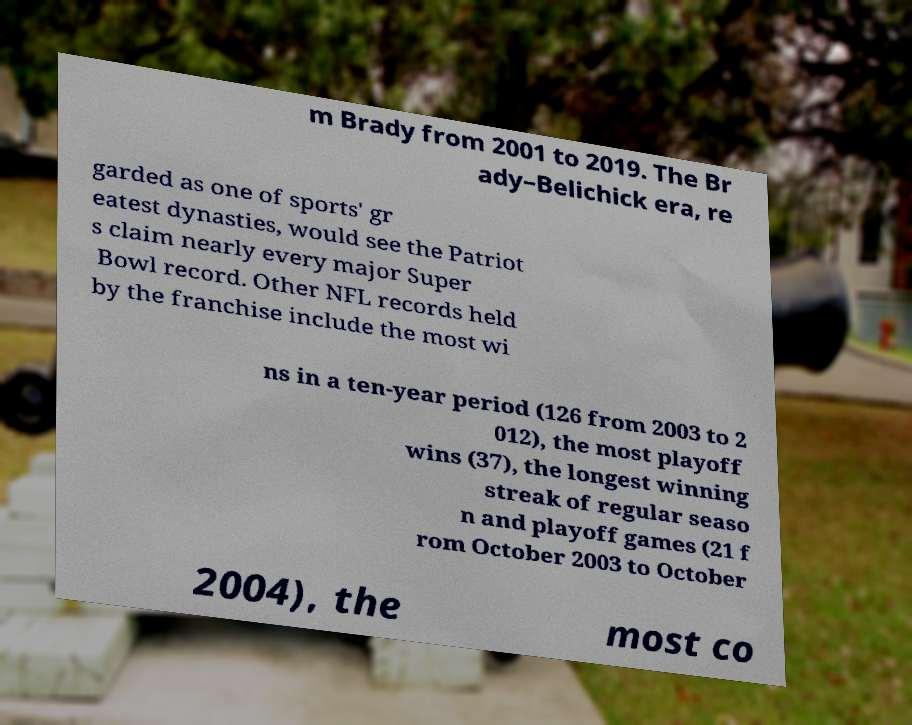For documentation purposes, I need the text within this image transcribed. Could you provide that? m Brady from 2001 to 2019. The Br ady–Belichick era, re garded as one of sports' gr eatest dynasties, would see the Patriot s claim nearly every major Super Bowl record. Other NFL records held by the franchise include the most wi ns in a ten-year period (126 from 2003 to 2 012), the most playoff wins (37), the longest winning streak of regular seaso n and playoff games (21 f rom October 2003 to October 2004), the most co 